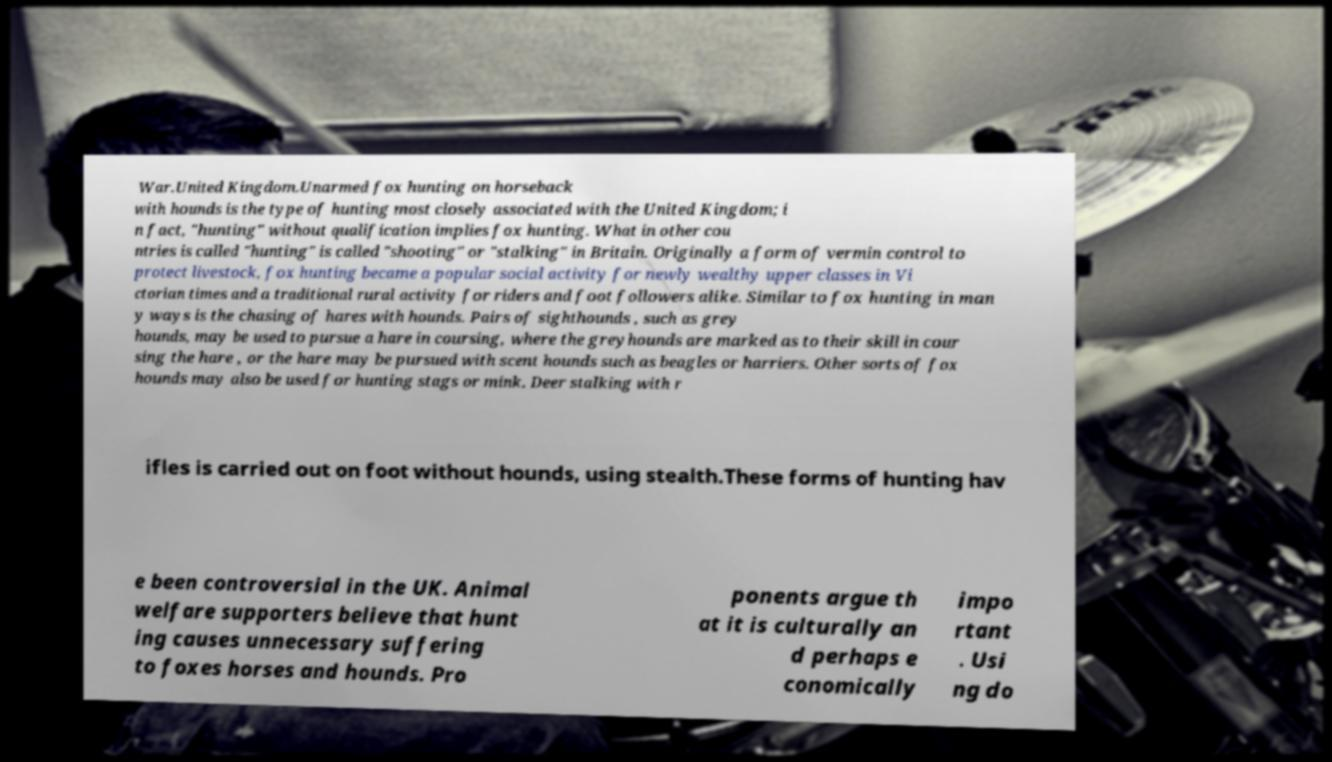Can you read and provide the text displayed in the image?This photo seems to have some interesting text. Can you extract and type it out for me? War.United Kingdom.Unarmed fox hunting on horseback with hounds is the type of hunting most closely associated with the United Kingdom; i n fact, "hunting" without qualification implies fox hunting. What in other cou ntries is called "hunting" is called "shooting" or "stalking" in Britain. Originally a form of vermin control to protect livestock, fox hunting became a popular social activity for newly wealthy upper classes in Vi ctorian times and a traditional rural activity for riders and foot followers alike. Similar to fox hunting in man y ways is the chasing of hares with hounds. Pairs of sighthounds , such as grey hounds, may be used to pursue a hare in coursing, where the greyhounds are marked as to their skill in cour sing the hare , or the hare may be pursued with scent hounds such as beagles or harriers. Other sorts of fox hounds may also be used for hunting stags or mink. Deer stalking with r ifles is carried out on foot without hounds, using stealth.These forms of hunting hav e been controversial in the UK. Animal welfare supporters believe that hunt ing causes unnecessary suffering to foxes horses and hounds. Pro ponents argue th at it is culturally an d perhaps e conomically impo rtant . Usi ng do 